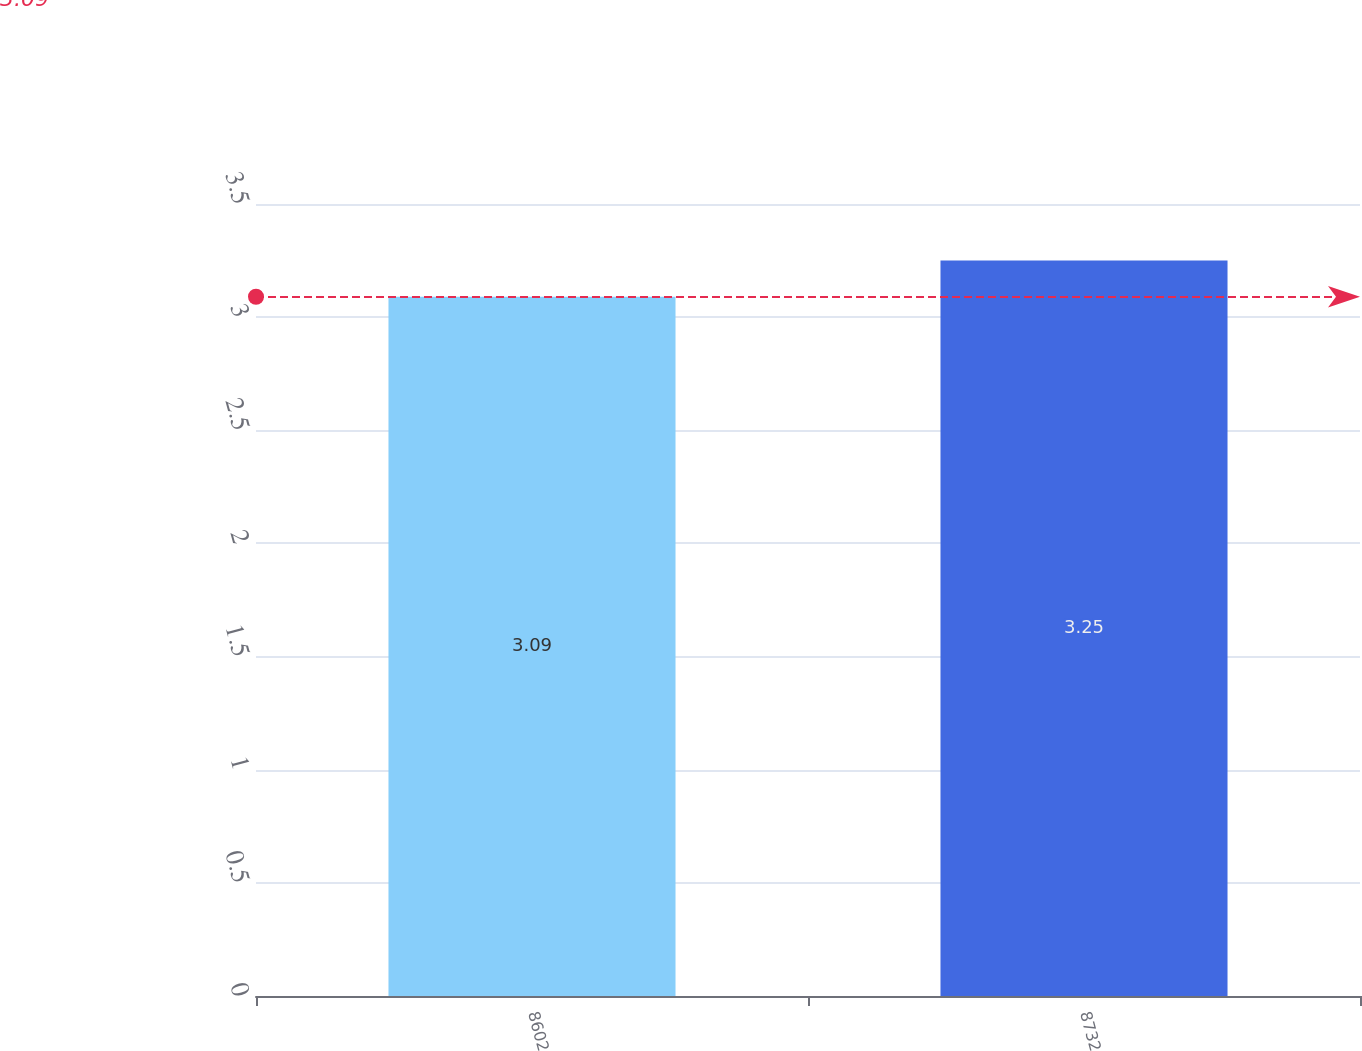Convert chart. <chart><loc_0><loc_0><loc_500><loc_500><bar_chart><fcel>8602<fcel>8732<nl><fcel>3.09<fcel>3.25<nl></chart> 